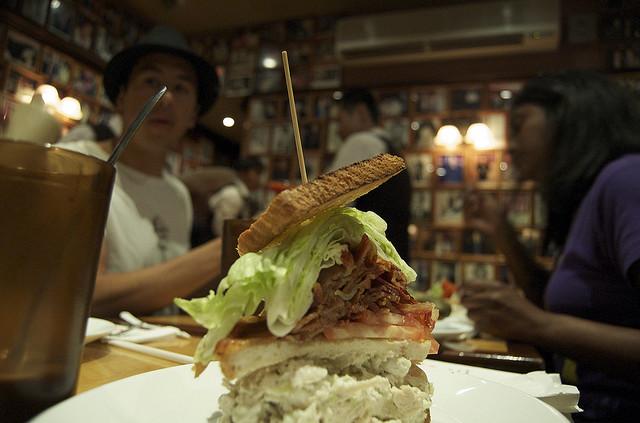How many toothpicks are in the sandwich?
Quick response, please. 1. Is the cup full?
Answer briefly. No. What type of sandwich is this?
Quick response, please. Steak sandwich. What kind of sandwich is in the picture?
Be succinct. Club. Where is the sandwich?
Concise answer only. Plate. 